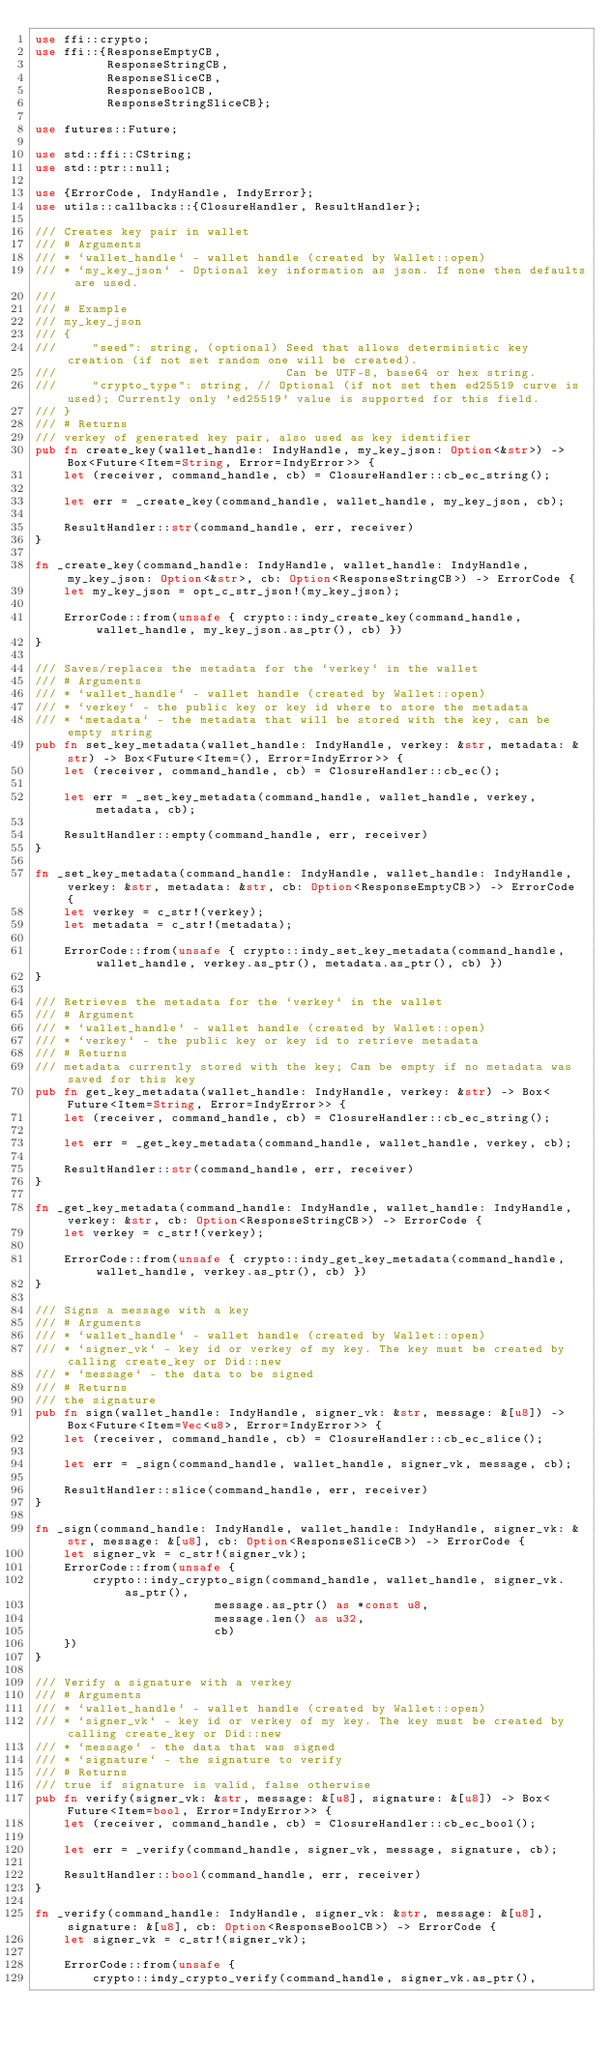<code> <loc_0><loc_0><loc_500><loc_500><_Rust_>use ffi::crypto;
use ffi::{ResponseEmptyCB,
          ResponseStringCB,
          ResponseSliceCB,
          ResponseBoolCB,
          ResponseStringSliceCB};

use futures::Future;

use std::ffi::CString;
use std::ptr::null;

use {ErrorCode, IndyHandle, IndyError};
use utils::callbacks::{ClosureHandler, ResultHandler};

/// Creates key pair in wallet
/// # Arguments
/// * `wallet_handle` - wallet handle (created by Wallet::open)
/// * `my_key_json` - Optional key information as json. If none then defaults are used.
///
/// # Example
/// my_key_json
/// {
///     "seed": string, (optional) Seed that allows deterministic key creation (if not set random one will be created).
///                                Can be UTF-8, base64 or hex string.
///     "crypto_type": string, // Optional (if not set then ed25519 curve is used); Currently only 'ed25519' value is supported for this field.
/// }
/// # Returns
/// verkey of generated key pair, also used as key identifier
pub fn create_key(wallet_handle: IndyHandle, my_key_json: Option<&str>) -> Box<Future<Item=String, Error=IndyError>> {
    let (receiver, command_handle, cb) = ClosureHandler::cb_ec_string();

    let err = _create_key(command_handle, wallet_handle, my_key_json, cb);

    ResultHandler::str(command_handle, err, receiver)
}

fn _create_key(command_handle: IndyHandle, wallet_handle: IndyHandle, my_key_json: Option<&str>, cb: Option<ResponseStringCB>) -> ErrorCode {
    let my_key_json = opt_c_str_json!(my_key_json);

    ErrorCode::from(unsafe { crypto::indy_create_key(command_handle, wallet_handle, my_key_json.as_ptr(), cb) })
}

/// Saves/replaces the metadata for the `verkey` in the wallet
/// # Arguments
/// * `wallet_handle` - wallet handle (created by Wallet::open)
/// * `verkey` - the public key or key id where to store the metadata
/// * `metadata` - the metadata that will be stored with the key, can be empty string
pub fn set_key_metadata(wallet_handle: IndyHandle, verkey: &str, metadata: &str) -> Box<Future<Item=(), Error=IndyError>> {
    let (receiver, command_handle, cb) = ClosureHandler::cb_ec();

    let err = _set_key_metadata(command_handle, wallet_handle, verkey, metadata, cb);

    ResultHandler::empty(command_handle, err, receiver)
}

fn _set_key_metadata(command_handle: IndyHandle, wallet_handle: IndyHandle, verkey: &str, metadata: &str, cb: Option<ResponseEmptyCB>) -> ErrorCode {
    let verkey = c_str!(verkey);
    let metadata = c_str!(metadata);

    ErrorCode::from(unsafe { crypto::indy_set_key_metadata(command_handle, wallet_handle, verkey.as_ptr(), metadata.as_ptr(), cb) })
}

/// Retrieves the metadata for the `verkey` in the wallet
/// # Argument
/// * `wallet_handle` - wallet handle (created by Wallet::open)
/// * `verkey` - the public key or key id to retrieve metadata
/// # Returns
/// metadata currently stored with the key; Can be empty if no metadata was saved for this key
pub fn get_key_metadata(wallet_handle: IndyHandle, verkey: &str) -> Box<Future<Item=String, Error=IndyError>> {
    let (receiver, command_handle, cb) = ClosureHandler::cb_ec_string();

    let err = _get_key_metadata(command_handle, wallet_handle, verkey, cb);

    ResultHandler::str(command_handle, err, receiver)
}

fn _get_key_metadata(command_handle: IndyHandle, wallet_handle: IndyHandle, verkey: &str, cb: Option<ResponseStringCB>) -> ErrorCode {
    let verkey = c_str!(verkey);

    ErrorCode::from(unsafe { crypto::indy_get_key_metadata(command_handle, wallet_handle, verkey.as_ptr(), cb) })
}

/// Signs a message with a key
/// # Arguments
/// * `wallet_handle` - wallet handle (created by Wallet::open)
/// * `signer_vk` - key id or verkey of my key. The key must be created by calling create_key or Did::new
/// * `message` - the data to be signed
/// # Returns
/// the signature
pub fn sign(wallet_handle: IndyHandle, signer_vk: &str, message: &[u8]) -> Box<Future<Item=Vec<u8>, Error=IndyError>> {
    let (receiver, command_handle, cb) = ClosureHandler::cb_ec_slice();

    let err = _sign(command_handle, wallet_handle, signer_vk, message, cb);

    ResultHandler::slice(command_handle, err, receiver)
}

fn _sign(command_handle: IndyHandle, wallet_handle: IndyHandle, signer_vk: &str, message: &[u8], cb: Option<ResponseSliceCB>) -> ErrorCode {
    let signer_vk = c_str!(signer_vk);
    ErrorCode::from(unsafe {
        crypto::indy_crypto_sign(command_handle, wallet_handle, signer_vk.as_ptr(),
                         message.as_ptr() as *const u8,
                         message.len() as u32,
                         cb)
    })
}

/// Verify a signature with a verkey
/// # Arguments
/// * `wallet_handle` - wallet handle (created by Wallet::open)
/// * `signer_vk` - key id or verkey of my key. The key must be created by calling create_key or Did::new
/// * `message` - the data that was signed
/// * `signature` - the signature to verify
/// # Returns
/// true if signature is valid, false otherwise
pub fn verify(signer_vk: &str, message: &[u8], signature: &[u8]) -> Box<Future<Item=bool, Error=IndyError>> {
    let (receiver, command_handle, cb) = ClosureHandler::cb_ec_bool();

    let err = _verify(command_handle, signer_vk, message, signature, cb);

    ResultHandler::bool(command_handle, err, receiver)
}

fn _verify(command_handle: IndyHandle, signer_vk: &str, message: &[u8], signature: &[u8], cb: Option<ResponseBoolCB>) -> ErrorCode {
    let signer_vk = c_str!(signer_vk);

    ErrorCode::from(unsafe {
        crypto::indy_crypto_verify(command_handle, signer_vk.as_ptr(),</code> 